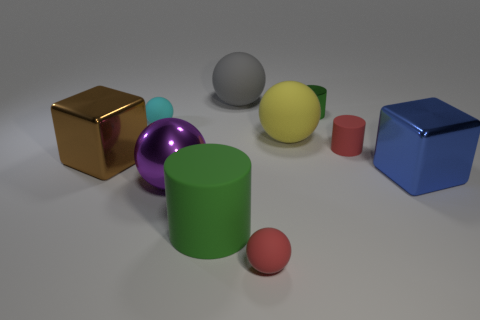Subtract all yellow cylinders. Subtract all yellow spheres. How many cylinders are left? 3 Subtract all green cylinders. How many brown blocks are left? 1 Add 9 tiny things. How many large purples exist? 0 Subtract all spheres. Subtract all green rubber cylinders. How many objects are left? 4 Add 3 big blue cubes. How many big blue cubes are left? 4 Add 1 small red things. How many small red things exist? 3 Subtract all brown cubes. How many cubes are left? 1 Subtract all small cyan balls. How many balls are left? 4 Subtract 1 yellow spheres. How many objects are left? 9 Subtract all cylinders. How many objects are left? 7 